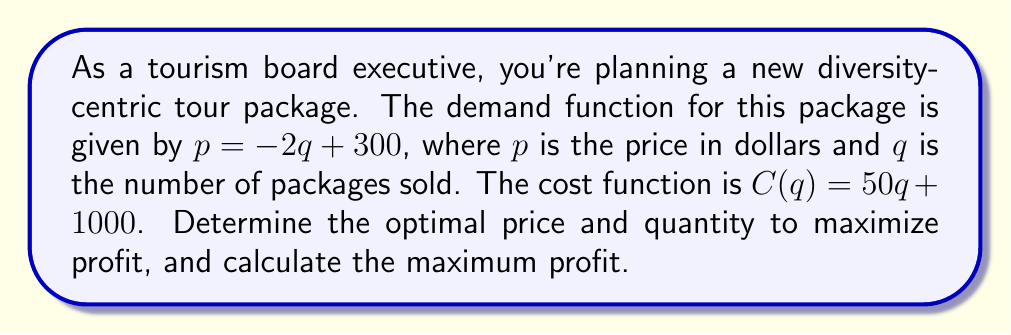Solve this math problem. To solve this problem, we'll follow these steps:

1. Define the profit function
2. Find the derivative of the profit function
3. Set the derivative to zero and solve for q
4. Calculate the optimal price
5. Calculate the maximum profit

Step 1: Define the profit function
Profit = Revenue - Cost
$\Pi(q) = pq - C(q)$

Substituting the demand function and cost function:
$\Pi(q) = (-2q + 300)q - (50q + 1000)$
$\Pi(q) = -2q^2 + 300q - 50q - 1000$
$\Pi(q) = -2q^2 + 250q - 1000$

Step 2: Find the derivative of the profit function
$$\frac{d\Pi}{dq} = -4q + 250$$

Step 3: Set the derivative to zero and solve for q
$$-4q + 250 = 0$$
$$-4q = -250$$
$$q = 62.5$$

The optimal quantity is 62.5 packages.

Step 4: Calculate the optimal price
Using the demand function:
$p = -2q + 300$
$p = -2(62.5) + 300$
$p = 175$

The optimal price is $175 per package.

Step 5: Calculate the maximum profit
$\Pi(62.5) = -2(62.5)^2 + 250(62.5) - 1000$
$\Pi(62.5) = -7812.5 + 15625 - 1000$
$\Pi(62.5) = 6812.5$
Answer: The optimal price is $175 per package, the optimal quantity is 62.5 packages, and the maximum profit is $6,812.50. 